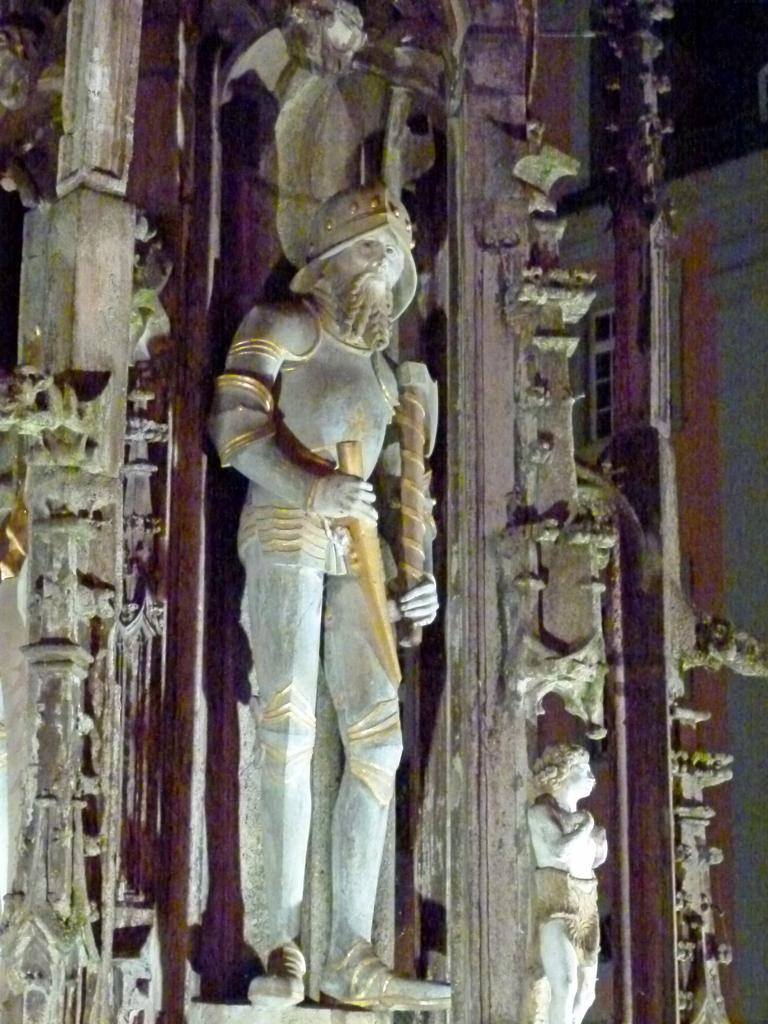What type of object is depicted in the image? There is a person statue in the image. What architectural features can be seen in the image? There are pillars in the image. What can be seen in the background of the image? There is a building in the background of the image. What type of iron is being used to serve food on a tray in the image? There is no iron or tray present in the image; it features a person statue and pillars. 